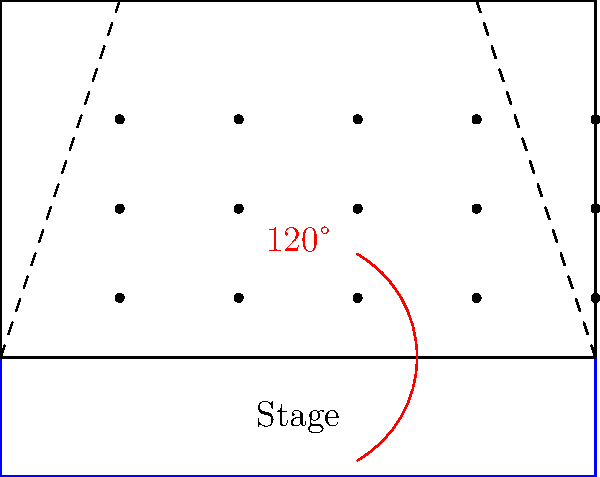In a comedy club, the optimal viewing angle for audience members is typically 120°. Given the floor plan shown, where the stage is represented by the blue rectangle and dots represent seats, what is the maximum distance from the front of the stage where seats should be placed to ensure all audience members have an optimal viewing experience? To solve this problem, we'll follow these steps:

1) The optimal viewing angle is given as 120°. This means the angle formed between the edges of the stage and the viewer should be 120°.

2) We can split this angle into two 60° angles on either side of the center line.

3) In a right-angled triangle, the tangent of 60° is $\tan(60°) = \sqrt{3} \approx 1.732$.

4) If we consider the width of the stage as $w$ and the maximum distance as $d$, we can set up the equation:

   $\frac{w/2}{d} = \tan(60°) = \sqrt{3}$

5) Rearranging this equation:

   $d = \frac{w}{2\sqrt{3}}$

6) From the floor plan, we can see that the stage width is 10 units.

7) Substituting this into our equation:

   $d = \frac{10}{2\sqrt{3}} \approx 2.887$ units

Therefore, the maximum distance from the front of the stage for optimal viewing is approximately 2.887 units.
Answer: $\frac{10}{2\sqrt{3}}$ units (≈ 2.887 units) 